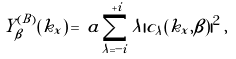<formula> <loc_0><loc_0><loc_500><loc_500>Y _ { \beta } ^ { ( B ) } ( k _ { x } ) \, = \, a \sum _ { \lambda = - i } ^ { + i } \lambda | c _ { \lambda } ( k _ { x } , \beta ) | ^ { 2 } \, ,</formula> 